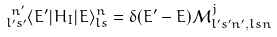<formula> <loc_0><loc_0><loc_500><loc_500>& { ^ { \ n ^ { \prime } } _ { l ^ { \prime } s ^ { \prime } } } \langle E ^ { \prime } | H _ { I } | E \rangle _ { l s } ^ { n } = \delta { ( E ^ { \prime } - E ) } \mathcal { M } ^ { j } _ { l ^ { \prime } s ^ { \prime } n ^ { \prime } , l s n }</formula> 